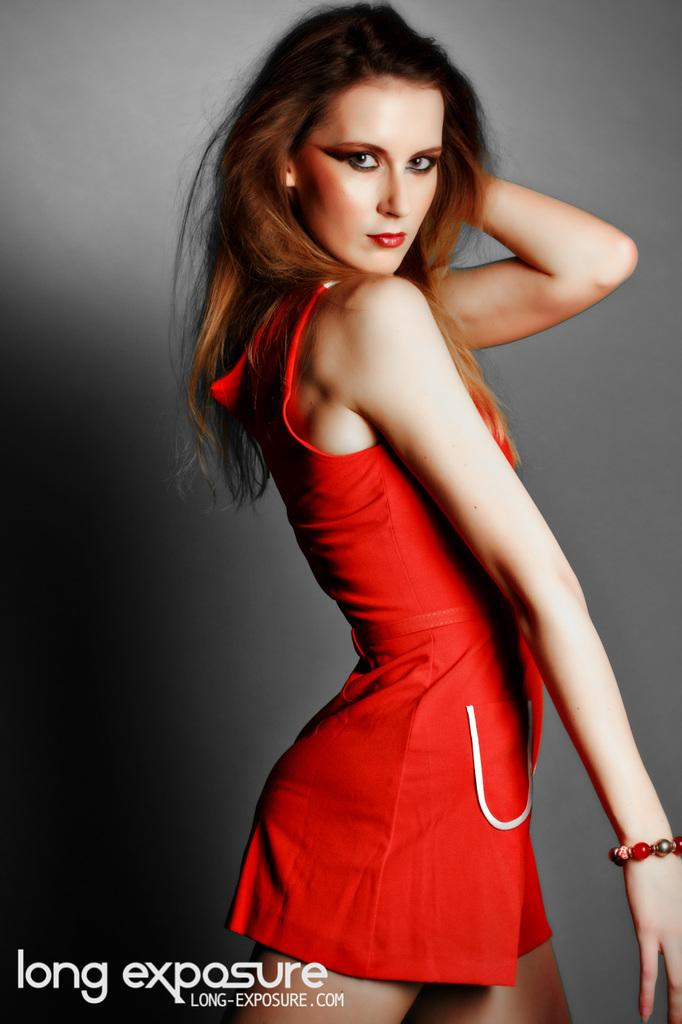<image>
Provide a brief description of the given image. The photo of the model is by long exposure whose website is LONG-EXPOSURE.COM. 